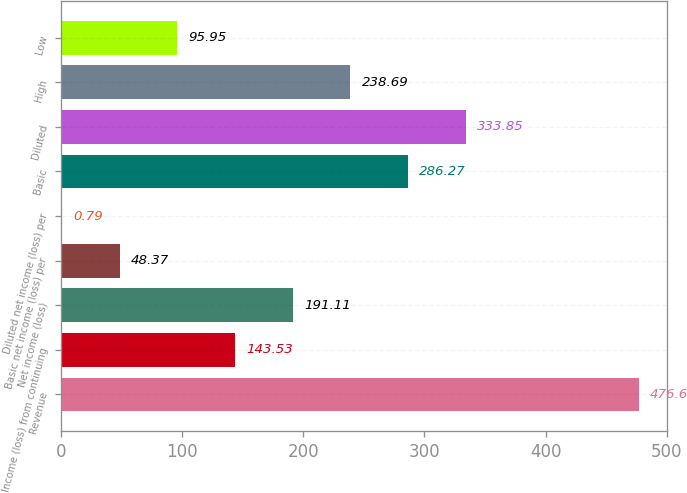<chart> <loc_0><loc_0><loc_500><loc_500><bar_chart><fcel>Revenue<fcel>Income (loss) from continuing<fcel>Net income (loss)<fcel>Basic net income (loss) per<fcel>Diluted net income (loss) per<fcel>Basic<fcel>Diluted<fcel>High<fcel>Low<nl><fcel>476.6<fcel>143.53<fcel>191.11<fcel>48.37<fcel>0.79<fcel>286.27<fcel>333.85<fcel>238.69<fcel>95.95<nl></chart> 